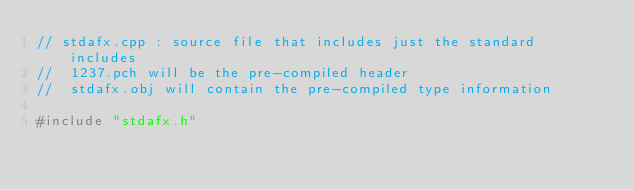Convert code to text. <code><loc_0><loc_0><loc_500><loc_500><_C++_>// stdafx.cpp : source file that includes just the standard includes
//	1237.pch will be the pre-compiled header
//	stdafx.obj will contain the pre-compiled type information

#include "stdafx.h"



</code> 